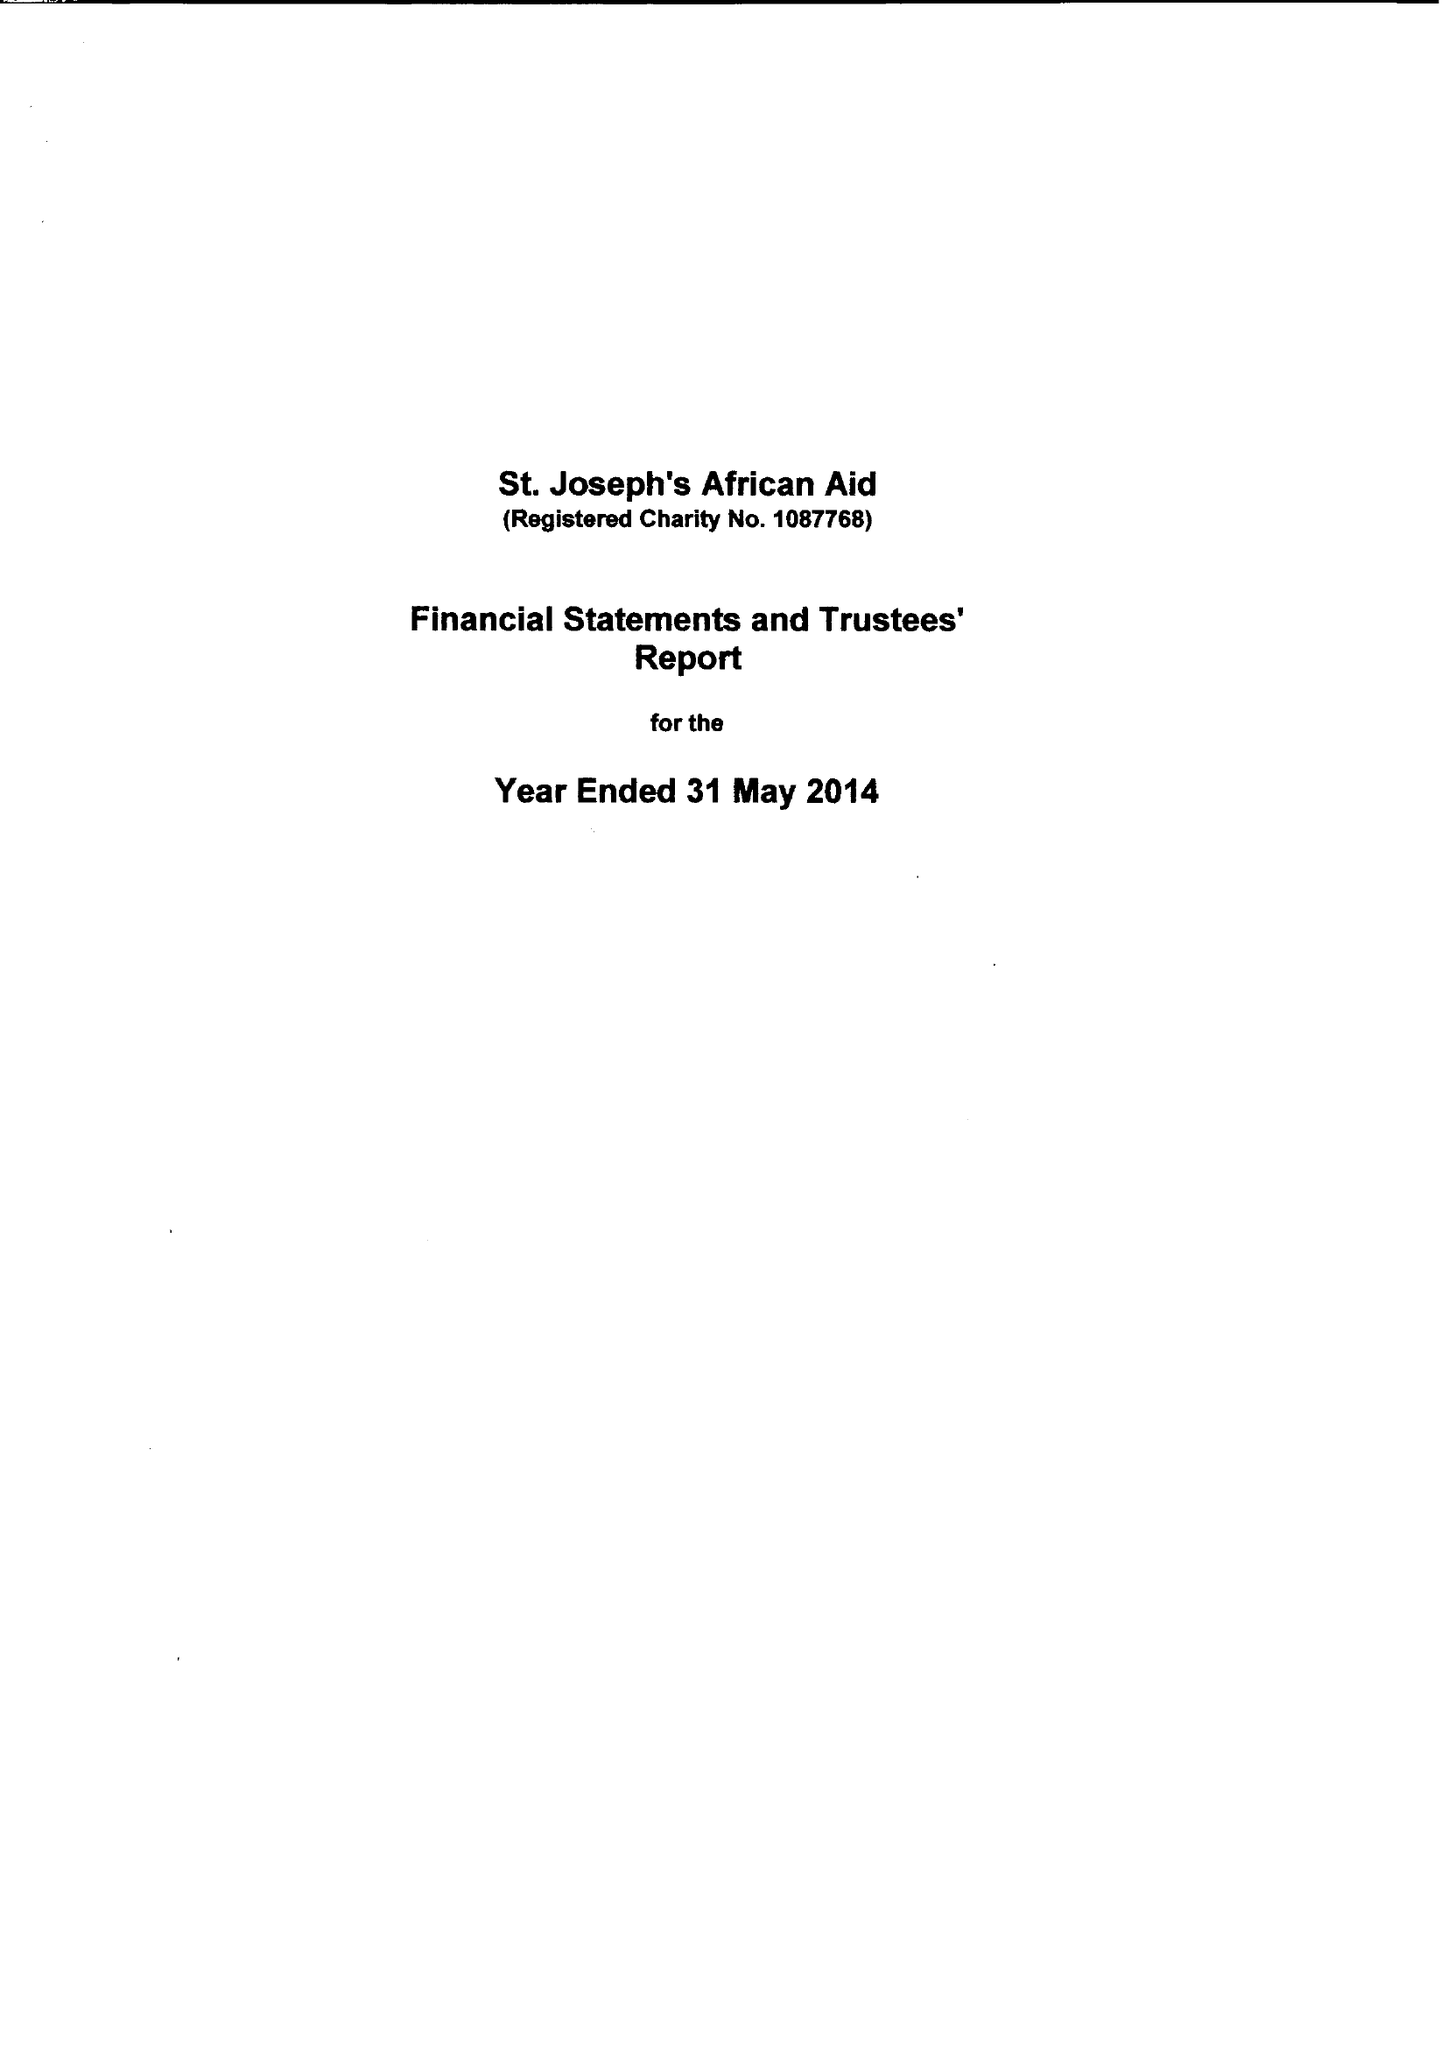What is the value for the address__postcode?
Answer the question using a single word or phrase. TW19 6AF 